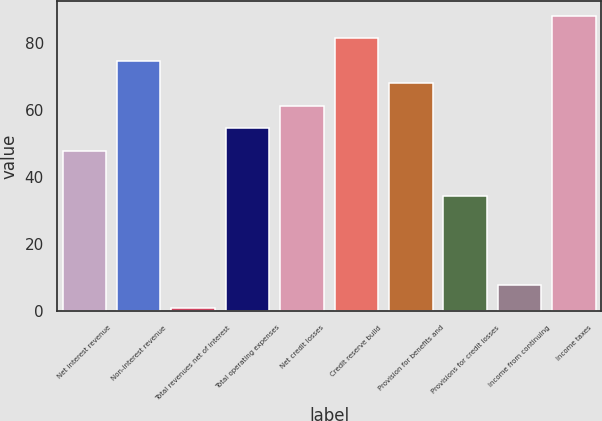Convert chart. <chart><loc_0><loc_0><loc_500><loc_500><bar_chart><fcel>Net interest revenue<fcel>Non-interest revenue<fcel>Total revenues net of interest<fcel>Total operating expenses<fcel>Net credit losses<fcel>Credit reserve build<fcel>Provision for benefits and<fcel>Provisions for credit losses<fcel>Income from continuing<fcel>Income taxes<nl><fcel>47.9<fcel>74.7<fcel>1<fcel>54.6<fcel>61.3<fcel>81.4<fcel>68<fcel>34.5<fcel>7.7<fcel>88.1<nl></chart> 